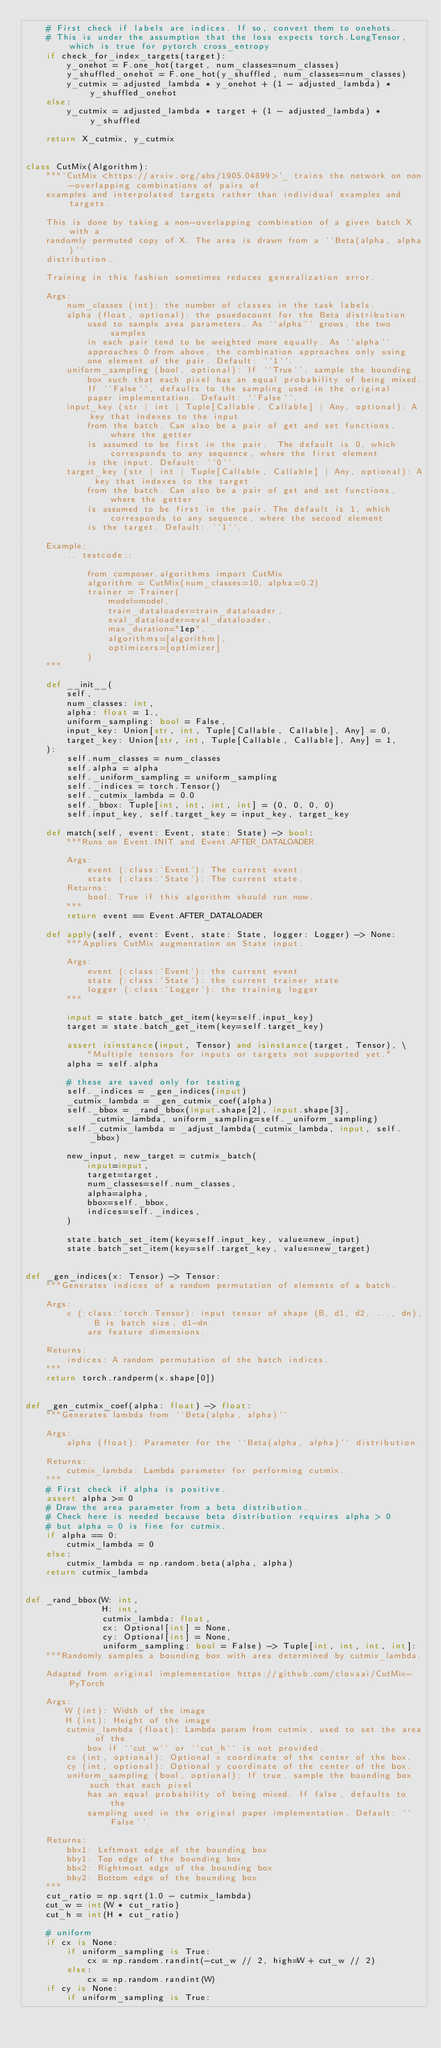Convert code to text. <code><loc_0><loc_0><loc_500><loc_500><_Python_>    # First check if labels are indices. If so, convert them to onehots.
    # This is under the assumption that the loss expects torch.LongTensor, which is true for pytorch cross_entropy
    if check_for_index_targets(target):
        y_onehot = F.one_hot(target, num_classes=num_classes)
        y_shuffled_onehot = F.one_hot(y_shuffled, num_classes=num_classes)
        y_cutmix = adjusted_lambda * y_onehot + (1 - adjusted_lambda) * y_shuffled_onehot
    else:
        y_cutmix = adjusted_lambda * target + (1 - adjusted_lambda) * y_shuffled

    return X_cutmix, y_cutmix


class CutMix(Algorithm):
    """`CutMix <https://arxiv.org/abs/1905.04899>`_ trains the network on non-overlapping combinations of pairs of
    examples and interpolated targets rather than individual examples and targets.

    This is done by taking a non-overlapping combination of a given batch X with a
    randomly permuted copy of X. The area is drawn from a ``Beta(alpha, alpha)``
    distribution.

    Training in this fashion sometimes reduces generalization error.

    Args:
        num_classes (int): the number of classes in the task labels.
        alpha (float, optional): the psuedocount for the Beta distribution
            used to sample area parameters. As ``alpha`` grows, the two samples
            in each pair tend to be weighted more equally. As ``alpha``
            approaches 0 from above, the combination approaches only using
            one element of the pair. Default: ``1``.
        uniform_sampling (bool, optional): If ``True``, sample the bounding
            box such that each pixel has an equal probability of being mixed.
            If ``False``, defaults to the sampling used in the original
            paper implementation. Default: ``False``.
        input_key (str | int | Tuple[Callable, Callable] | Any, optional): A key that indexes to the input
            from the batch. Can also be a pair of get and set functions, where the getter
            is assumed to be first in the pair.  The default is 0, which corresponds to any sequence, where the first element
            is the input. Default: ``0``.
        target_key (str | int | Tuple[Callable, Callable] | Any, optional): A key that indexes to the target
            from the batch. Can also be a pair of get and set functions, where the getter
            is assumed to be first in the pair. The default is 1, which corresponds to any sequence, where the second element
            is the target. Default: ``1``.

    Example:
        .. testcode::

            from composer.algorithms import CutMix
            algorithm = CutMix(num_classes=10, alpha=0.2)
            trainer = Trainer(
                model=model,
                train_dataloader=train_dataloader,
                eval_dataloader=eval_dataloader,
                max_duration="1ep",
                algorithms=[algorithm],
                optimizers=[optimizer]
            )
    """

    def __init__(
        self,
        num_classes: int,
        alpha: float = 1.,
        uniform_sampling: bool = False,
        input_key: Union[str, int, Tuple[Callable, Callable], Any] = 0,
        target_key: Union[str, int, Tuple[Callable, Callable], Any] = 1,
    ):
        self.num_classes = num_classes
        self.alpha = alpha
        self._uniform_sampling = uniform_sampling
        self._indices = torch.Tensor()
        self._cutmix_lambda = 0.0
        self._bbox: Tuple[int, int, int, int] = (0, 0, 0, 0)
        self.input_key, self.target_key = input_key, target_key

    def match(self, event: Event, state: State) -> bool:
        """Runs on Event.INIT and Event.AFTER_DATALOADER.

        Args:
            event (:class:`Event`): The current event.
            state (:class:`State`): The current state.
        Returns:
            bool: True if this algorithm should run now.
        """
        return event == Event.AFTER_DATALOADER

    def apply(self, event: Event, state: State, logger: Logger) -> None:
        """Applies CutMix augmentation on State input.

        Args:
            event (:class:`Event`): the current event
            state (:class:`State`): the current trainer state
            logger (:class:`Logger`): the training logger
        """

        input = state.batch_get_item(key=self.input_key)
        target = state.batch_get_item(key=self.target_key)

        assert isinstance(input, Tensor) and isinstance(target, Tensor), \
            "Multiple tensors for inputs or targets not supported yet."
        alpha = self.alpha

        # these are saved only for testing
        self._indices = _gen_indices(input)
        _cutmix_lambda = _gen_cutmix_coef(alpha)
        self._bbox = _rand_bbox(input.shape[2], input.shape[3], _cutmix_lambda, uniform_sampling=self._uniform_sampling)
        self._cutmix_lambda = _adjust_lambda(_cutmix_lambda, input, self._bbox)

        new_input, new_target = cutmix_batch(
            input=input,
            target=target,
            num_classes=self.num_classes,
            alpha=alpha,
            bbox=self._bbox,
            indices=self._indices,
        )

        state.batch_set_item(key=self.input_key, value=new_input)
        state.batch_set_item(key=self.target_key, value=new_target)


def _gen_indices(x: Tensor) -> Tensor:
    """Generates indices of a random permutation of elements of a batch.

    Args:
        x (:class:`torch.Tensor): input tensor of shape (B, d1, d2, ..., dn), B is batch size, d1-dn
            are feature dimensions.

    Returns:
        indices: A random permutation of the batch indices.
    """
    return torch.randperm(x.shape[0])


def _gen_cutmix_coef(alpha: float) -> float:
    """Generates lambda from ``Beta(alpha, alpha)``

    Args:
        alpha (float): Parameter for the ``Beta(alpha, alpha)`` distribution

    Returns:
        cutmix_lambda: Lambda parameter for performing cutmix.
    """
    # First check if alpha is positive.
    assert alpha >= 0
    # Draw the area parameter from a beta distribution.
    # Check here is needed because beta distribution requires alpha > 0
    # but alpha = 0 is fine for cutmix.
    if alpha == 0:
        cutmix_lambda = 0
    else:
        cutmix_lambda = np.random.beta(alpha, alpha)
    return cutmix_lambda


def _rand_bbox(W: int,
               H: int,
               cutmix_lambda: float,
               cx: Optional[int] = None,
               cy: Optional[int] = None,
               uniform_sampling: bool = False) -> Tuple[int, int, int, int]:
    """Randomly samples a bounding box with area determined by cutmix_lambda.

    Adapted from original implementation https://github.com/clovaai/CutMix-PyTorch

    Args:
        W (int): Width of the image
        H (int): Height of the image
        cutmix_lambda (float): Lambda param from cutmix, used to set the area of the
            box if ``cut_w`` or ``cut_h`` is not provided.
        cx (int, optional): Optional x coordinate of the center of the box.
        cy (int, optional): Optional y coordinate of the center of the box.
        uniform_sampling (bool, optional): If true, sample the bounding box such that each pixel
            has an equal probability of being mixed. If false, defaults to the
            sampling used in the original paper implementation. Default: ``False``.

    Returns:
        bbx1: Leftmost edge of the bounding box
        bby1: Top edge of the bounding box
        bbx2: Rightmost edge of the bounding box
        bby2: Bottom edge of the bounding box
    """
    cut_ratio = np.sqrt(1.0 - cutmix_lambda)
    cut_w = int(W * cut_ratio)
    cut_h = int(H * cut_ratio)

    # uniform
    if cx is None:
        if uniform_sampling is True:
            cx = np.random.randint(-cut_w // 2, high=W + cut_w // 2)
        else:
            cx = np.random.randint(W)
    if cy is None:
        if uniform_sampling is True:</code> 